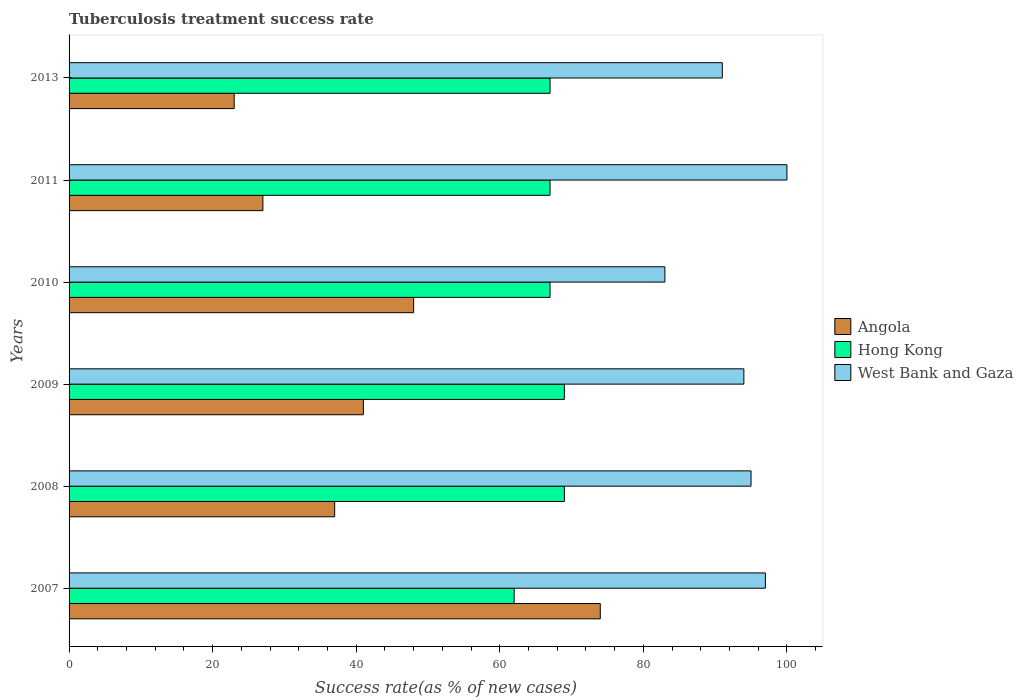How many groups of bars are there?
Your answer should be compact. 6. Are the number of bars per tick equal to the number of legend labels?
Provide a succinct answer. Yes. How many bars are there on the 5th tick from the bottom?
Offer a very short reply. 3. What is the label of the 1st group of bars from the top?
Provide a short and direct response. 2013. In how many cases, is the number of bars for a given year not equal to the number of legend labels?
Your response must be concise. 0. What is the tuberculosis treatment success rate in Angola in 2007?
Keep it short and to the point. 74. Across all years, what is the maximum tuberculosis treatment success rate in West Bank and Gaza?
Keep it short and to the point. 100. In which year was the tuberculosis treatment success rate in Angola maximum?
Give a very brief answer. 2007. What is the total tuberculosis treatment success rate in Angola in the graph?
Keep it short and to the point. 250. What is the difference between the tuberculosis treatment success rate in West Bank and Gaza in 2008 and that in 2009?
Provide a succinct answer. 1. What is the difference between the tuberculosis treatment success rate in Angola in 2007 and the tuberculosis treatment success rate in West Bank and Gaza in 2013?
Give a very brief answer. -17. What is the average tuberculosis treatment success rate in Hong Kong per year?
Keep it short and to the point. 66.83. In the year 2010, what is the difference between the tuberculosis treatment success rate in Hong Kong and tuberculosis treatment success rate in Angola?
Provide a short and direct response. 19. In how many years, is the tuberculosis treatment success rate in Hong Kong greater than 48 %?
Offer a very short reply. 6. What is the ratio of the tuberculosis treatment success rate in Hong Kong in 2008 to that in 2013?
Offer a very short reply. 1.03. Is the tuberculosis treatment success rate in Angola in 2007 less than that in 2009?
Offer a terse response. No. Is the difference between the tuberculosis treatment success rate in Hong Kong in 2009 and 2010 greater than the difference between the tuberculosis treatment success rate in Angola in 2009 and 2010?
Provide a short and direct response. Yes. What is the difference between the highest and the second highest tuberculosis treatment success rate in Hong Kong?
Offer a terse response. 0. In how many years, is the tuberculosis treatment success rate in Hong Kong greater than the average tuberculosis treatment success rate in Hong Kong taken over all years?
Offer a very short reply. 5. Is the sum of the tuberculosis treatment success rate in Hong Kong in 2009 and 2011 greater than the maximum tuberculosis treatment success rate in West Bank and Gaza across all years?
Give a very brief answer. Yes. What does the 3rd bar from the top in 2009 represents?
Ensure brevity in your answer.  Angola. What does the 1st bar from the bottom in 2009 represents?
Ensure brevity in your answer.  Angola. Is it the case that in every year, the sum of the tuberculosis treatment success rate in Hong Kong and tuberculosis treatment success rate in Angola is greater than the tuberculosis treatment success rate in West Bank and Gaza?
Your response must be concise. No. How many bars are there?
Provide a short and direct response. 18. Are all the bars in the graph horizontal?
Your answer should be compact. Yes. How many years are there in the graph?
Provide a succinct answer. 6. Does the graph contain any zero values?
Offer a very short reply. No. Does the graph contain grids?
Give a very brief answer. No. Where does the legend appear in the graph?
Provide a succinct answer. Center right. How are the legend labels stacked?
Your answer should be very brief. Vertical. What is the title of the graph?
Your response must be concise. Tuberculosis treatment success rate. Does "Lithuania" appear as one of the legend labels in the graph?
Keep it short and to the point. No. What is the label or title of the X-axis?
Give a very brief answer. Success rate(as % of new cases). What is the label or title of the Y-axis?
Your answer should be very brief. Years. What is the Success rate(as % of new cases) in Hong Kong in 2007?
Offer a terse response. 62. What is the Success rate(as % of new cases) of West Bank and Gaza in 2007?
Keep it short and to the point. 97. What is the Success rate(as % of new cases) of Hong Kong in 2008?
Make the answer very short. 69. What is the Success rate(as % of new cases) of Angola in 2009?
Your response must be concise. 41. What is the Success rate(as % of new cases) of West Bank and Gaza in 2009?
Offer a terse response. 94. What is the Success rate(as % of new cases) of Hong Kong in 2010?
Ensure brevity in your answer.  67. What is the Success rate(as % of new cases) in Hong Kong in 2013?
Your answer should be very brief. 67. What is the Success rate(as % of new cases) in West Bank and Gaza in 2013?
Offer a terse response. 91. Across all years, what is the maximum Success rate(as % of new cases) of Angola?
Offer a very short reply. 74. Across all years, what is the maximum Success rate(as % of new cases) of Hong Kong?
Make the answer very short. 69. Across all years, what is the minimum Success rate(as % of new cases) in Angola?
Provide a succinct answer. 23. What is the total Success rate(as % of new cases) in Angola in the graph?
Ensure brevity in your answer.  250. What is the total Success rate(as % of new cases) in Hong Kong in the graph?
Ensure brevity in your answer.  401. What is the total Success rate(as % of new cases) of West Bank and Gaza in the graph?
Ensure brevity in your answer.  560. What is the difference between the Success rate(as % of new cases) of Hong Kong in 2007 and that in 2008?
Keep it short and to the point. -7. What is the difference between the Success rate(as % of new cases) in West Bank and Gaza in 2007 and that in 2008?
Make the answer very short. 2. What is the difference between the Success rate(as % of new cases) in Hong Kong in 2007 and that in 2009?
Provide a succinct answer. -7. What is the difference between the Success rate(as % of new cases) in West Bank and Gaza in 2007 and that in 2009?
Give a very brief answer. 3. What is the difference between the Success rate(as % of new cases) of Angola in 2007 and that in 2010?
Provide a short and direct response. 26. What is the difference between the Success rate(as % of new cases) of Hong Kong in 2007 and that in 2010?
Provide a succinct answer. -5. What is the difference between the Success rate(as % of new cases) in Angola in 2007 and that in 2011?
Make the answer very short. 47. What is the difference between the Success rate(as % of new cases) in Hong Kong in 2007 and that in 2013?
Ensure brevity in your answer.  -5. What is the difference between the Success rate(as % of new cases) of West Bank and Gaza in 2007 and that in 2013?
Your answer should be very brief. 6. What is the difference between the Success rate(as % of new cases) of Angola in 2008 and that in 2010?
Ensure brevity in your answer.  -11. What is the difference between the Success rate(as % of new cases) of West Bank and Gaza in 2008 and that in 2011?
Offer a very short reply. -5. What is the difference between the Success rate(as % of new cases) of Angola in 2008 and that in 2013?
Ensure brevity in your answer.  14. What is the difference between the Success rate(as % of new cases) of Hong Kong in 2008 and that in 2013?
Offer a very short reply. 2. What is the difference between the Success rate(as % of new cases) in Angola in 2009 and that in 2010?
Ensure brevity in your answer.  -7. What is the difference between the Success rate(as % of new cases) in Hong Kong in 2009 and that in 2013?
Give a very brief answer. 2. What is the difference between the Success rate(as % of new cases) in West Bank and Gaza in 2009 and that in 2013?
Provide a succinct answer. 3. What is the difference between the Success rate(as % of new cases) in Angola in 2010 and that in 2011?
Your response must be concise. 21. What is the difference between the Success rate(as % of new cases) of West Bank and Gaza in 2010 and that in 2011?
Provide a succinct answer. -17. What is the difference between the Success rate(as % of new cases) of Hong Kong in 2010 and that in 2013?
Offer a very short reply. 0. What is the difference between the Success rate(as % of new cases) in Angola in 2007 and the Success rate(as % of new cases) in Hong Kong in 2008?
Provide a succinct answer. 5. What is the difference between the Success rate(as % of new cases) of Hong Kong in 2007 and the Success rate(as % of new cases) of West Bank and Gaza in 2008?
Ensure brevity in your answer.  -33. What is the difference between the Success rate(as % of new cases) of Angola in 2007 and the Success rate(as % of new cases) of West Bank and Gaza in 2009?
Offer a terse response. -20. What is the difference between the Success rate(as % of new cases) in Hong Kong in 2007 and the Success rate(as % of new cases) in West Bank and Gaza in 2009?
Keep it short and to the point. -32. What is the difference between the Success rate(as % of new cases) in Angola in 2007 and the Success rate(as % of new cases) in Hong Kong in 2010?
Provide a short and direct response. 7. What is the difference between the Success rate(as % of new cases) of Angola in 2007 and the Success rate(as % of new cases) of Hong Kong in 2011?
Make the answer very short. 7. What is the difference between the Success rate(as % of new cases) in Hong Kong in 2007 and the Success rate(as % of new cases) in West Bank and Gaza in 2011?
Give a very brief answer. -38. What is the difference between the Success rate(as % of new cases) in Hong Kong in 2007 and the Success rate(as % of new cases) in West Bank and Gaza in 2013?
Keep it short and to the point. -29. What is the difference between the Success rate(as % of new cases) of Angola in 2008 and the Success rate(as % of new cases) of Hong Kong in 2009?
Keep it short and to the point. -32. What is the difference between the Success rate(as % of new cases) of Angola in 2008 and the Success rate(as % of new cases) of West Bank and Gaza in 2009?
Offer a very short reply. -57. What is the difference between the Success rate(as % of new cases) of Hong Kong in 2008 and the Success rate(as % of new cases) of West Bank and Gaza in 2009?
Your response must be concise. -25. What is the difference between the Success rate(as % of new cases) of Angola in 2008 and the Success rate(as % of new cases) of Hong Kong in 2010?
Your response must be concise. -30. What is the difference between the Success rate(as % of new cases) in Angola in 2008 and the Success rate(as % of new cases) in West Bank and Gaza in 2010?
Offer a very short reply. -46. What is the difference between the Success rate(as % of new cases) of Angola in 2008 and the Success rate(as % of new cases) of West Bank and Gaza in 2011?
Give a very brief answer. -63. What is the difference between the Success rate(as % of new cases) of Hong Kong in 2008 and the Success rate(as % of new cases) of West Bank and Gaza in 2011?
Offer a very short reply. -31. What is the difference between the Success rate(as % of new cases) in Angola in 2008 and the Success rate(as % of new cases) in West Bank and Gaza in 2013?
Ensure brevity in your answer.  -54. What is the difference between the Success rate(as % of new cases) in Angola in 2009 and the Success rate(as % of new cases) in West Bank and Gaza in 2010?
Provide a short and direct response. -42. What is the difference between the Success rate(as % of new cases) of Hong Kong in 2009 and the Success rate(as % of new cases) of West Bank and Gaza in 2010?
Keep it short and to the point. -14. What is the difference between the Success rate(as % of new cases) in Angola in 2009 and the Success rate(as % of new cases) in West Bank and Gaza in 2011?
Your response must be concise. -59. What is the difference between the Success rate(as % of new cases) in Hong Kong in 2009 and the Success rate(as % of new cases) in West Bank and Gaza in 2011?
Offer a terse response. -31. What is the difference between the Success rate(as % of new cases) in Angola in 2009 and the Success rate(as % of new cases) in Hong Kong in 2013?
Offer a terse response. -26. What is the difference between the Success rate(as % of new cases) of Angola in 2010 and the Success rate(as % of new cases) of Hong Kong in 2011?
Give a very brief answer. -19. What is the difference between the Success rate(as % of new cases) in Angola in 2010 and the Success rate(as % of new cases) in West Bank and Gaza in 2011?
Offer a terse response. -52. What is the difference between the Success rate(as % of new cases) in Hong Kong in 2010 and the Success rate(as % of new cases) in West Bank and Gaza in 2011?
Offer a very short reply. -33. What is the difference between the Success rate(as % of new cases) of Angola in 2010 and the Success rate(as % of new cases) of Hong Kong in 2013?
Keep it short and to the point. -19. What is the difference between the Success rate(as % of new cases) of Angola in 2010 and the Success rate(as % of new cases) of West Bank and Gaza in 2013?
Give a very brief answer. -43. What is the difference between the Success rate(as % of new cases) of Hong Kong in 2010 and the Success rate(as % of new cases) of West Bank and Gaza in 2013?
Your answer should be very brief. -24. What is the difference between the Success rate(as % of new cases) in Angola in 2011 and the Success rate(as % of new cases) in West Bank and Gaza in 2013?
Offer a very short reply. -64. What is the difference between the Success rate(as % of new cases) of Hong Kong in 2011 and the Success rate(as % of new cases) of West Bank and Gaza in 2013?
Your answer should be very brief. -24. What is the average Success rate(as % of new cases) of Angola per year?
Offer a very short reply. 41.67. What is the average Success rate(as % of new cases) of Hong Kong per year?
Provide a short and direct response. 66.83. What is the average Success rate(as % of new cases) in West Bank and Gaza per year?
Offer a terse response. 93.33. In the year 2007, what is the difference between the Success rate(as % of new cases) of Angola and Success rate(as % of new cases) of Hong Kong?
Provide a short and direct response. 12. In the year 2007, what is the difference between the Success rate(as % of new cases) of Angola and Success rate(as % of new cases) of West Bank and Gaza?
Ensure brevity in your answer.  -23. In the year 2007, what is the difference between the Success rate(as % of new cases) of Hong Kong and Success rate(as % of new cases) of West Bank and Gaza?
Ensure brevity in your answer.  -35. In the year 2008, what is the difference between the Success rate(as % of new cases) in Angola and Success rate(as % of new cases) in Hong Kong?
Provide a succinct answer. -32. In the year 2008, what is the difference between the Success rate(as % of new cases) of Angola and Success rate(as % of new cases) of West Bank and Gaza?
Give a very brief answer. -58. In the year 2008, what is the difference between the Success rate(as % of new cases) in Hong Kong and Success rate(as % of new cases) in West Bank and Gaza?
Ensure brevity in your answer.  -26. In the year 2009, what is the difference between the Success rate(as % of new cases) in Angola and Success rate(as % of new cases) in West Bank and Gaza?
Offer a terse response. -53. In the year 2009, what is the difference between the Success rate(as % of new cases) of Hong Kong and Success rate(as % of new cases) of West Bank and Gaza?
Offer a very short reply. -25. In the year 2010, what is the difference between the Success rate(as % of new cases) in Angola and Success rate(as % of new cases) in Hong Kong?
Offer a terse response. -19. In the year 2010, what is the difference between the Success rate(as % of new cases) of Angola and Success rate(as % of new cases) of West Bank and Gaza?
Offer a terse response. -35. In the year 2010, what is the difference between the Success rate(as % of new cases) in Hong Kong and Success rate(as % of new cases) in West Bank and Gaza?
Your answer should be very brief. -16. In the year 2011, what is the difference between the Success rate(as % of new cases) of Angola and Success rate(as % of new cases) of Hong Kong?
Your response must be concise. -40. In the year 2011, what is the difference between the Success rate(as % of new cases) in Angola and Success rate(as % of new cases) in West Bank and Gaza?
Your response must be concise. -73. In the year 2011, what is the difference between the Success rate(as % of new cases) in Hong Kong and Success rate(as % of new cases) in West Bank and Gaza?
Provide a short and direct response. -33. In the year 2013, what is the difference between the Success rate(as % of new cases) in Angola and Success rate(as % of new cases) in Hong Kong?
Give a very brief answer. -44. In the year 2013, what is the difference between the Success rate(as % of new cases) of Angola and Success rate(as % of new cases) of West Bank and Gaza?
Make the answer very short. -68. In the year 2013, what is the difference between the Success rate(as % of new cases) in Hong Kong and Success rate(as % of new cases) in West Bank and Gaza?
Your answer should be compact. -24. What is the ratio of the Success rate(as % of new cases) of Hong Kong in 2007 to that in 2008?
Make the answer very short. 0.9. What is the ratio of the Success rate(as % of new cases) of West Bank and Gaza in 2007 to that in 2008?
Your answer should be compact. 1.02. What is the ratio of the Success rate(as % of new cases) in Angola in 2007 to that in 2009?
Your answer should be compact. 1.8. What is the ratio of the Success rate(as % of new cases) of Hong Kong in 2007 to that in 2009?
Provide a short and direct response. 0.9. What is the ratio of the Success rate(as % of new cases) of West Bank and Gaza in 2007 to that in 2009?
Ensure brevity in your answer.  1.03. What is the ratio of the Success rate(as % of new cases) in Angola in 2007 to that in 2010?
Give a very brief answer. 1.54. What is the ratio of the Success rate(as % of new cases) in Hong Kong in 2007 to that in 2010?
Your answer should be compact. 0.93. What is the ratio of the Success rate(as % of new cases) in West Bank and Gaza in 2007 to that in 2010?
Your response must be concise. 1.17. What is the ratio of the Success rate(as % of new cases) in Angola in 2007 to that in 2011?
Keep it short and to the point. 2.74. What is the ratio of the Success rate(as % of new cases) in Hong Kong in 2007 to that in 2011?
Provide a succinct answer. 0.93. What is the ratio of the Success rate(as % of new cases) in Angola in 2007 to that in 2013?
Provide a short and direct response. 3.22. What is the ratio of the Success rate(as % of new cases) in Hong Kong in 2007 to that in 2013?
Your response must be concise. 0.93. What is the ratio of the Success rate(as % of new cases) of West Bank and Gaza in 2007 to that in 2013?
Offer a terse response. 1.07. What is the ratio of the Success rate(as % of new cases) in Angola in 2008 to that in 2009?
Offer a terse response. 0.9. What is the ratio of the Success rate(as % of new cases) in Hong Kong in 2008 to that in 2009?
Make the answer very short. 1. What is the ratio of the Success rate(as % of new cases) of West Bank and Gaza in 2008 to that in 2009?
Give a very brief answer. 1.01. What is the ratio of the Success rate(as % of new cases) of Angola in 2008 to that in 2010?
Give a very brief answer. 0.77. What is the ratio of the Success rate(as % of new cases) of Hong Kong in 2008 to that in 2010?
Keep it short and to the point. 1.03. What is the ratio of the Success rate(as % of new cases) in West Bank and Gaza in 2008 to that in 2010?
Your response must be concise. 1.14. What is the ratio of the Success rate(as % of new cases) in Angola in 2008 to that in 2011?
Keep it short and to the point. 1.37. What is the ratio of the Success rate(as % of new cases) of Hong Kong in 2008 to that in 2011?
Keep it short and to the point. 1.03. What is the ratio of the Success rate(as % of new cases) of Angola in 2008 to that in 2013?
Provide a short and direct response. 1.61. What is the ratio of the Success rate(as % of new cases) in Hong Kong in 2008 to that in 2013?
Give a very brief answer. 1.03. What is the ratio of the Success rate(as % of new cases) of West Bank and Gaza in 2008 to that in 2013?
Give a very brief answer. 1.04. What is the ratio of the Success rate(as % of new cases) of Angola in 2009 to that in 2010?
Provide a succinct answer. 0.85. What is the ratio of the Success rate(as % of new cases) of Hong Kong in 2009 to that in 2010?
Your response must be concise. 1.03. What is the ratio of the Success rate(as % of new cases) of West Bank and Gaza in 2009 to that in 2010?
Ensure brevity in your answer.  1.13. What is the ratio of the Success rate(as % of new cases) of Angola in 2009 to that in 2011?
Provide a short and direct response. 1.52. What is the ratio of the Success rate(as % of new cases) of Hong Kong in 2009 to that in 2011?
Provide a succinct answer. 1.03. What is the ratio of the Success rate(as % of new cases) in Angola in 2009 to that in 2013?
Offer a terse response. 1.78. What is the ratio of the Success rate(as % of new cases) in Hong Kong in 2009 to that in 2013?
Provide a succinct answer. 1.03. What is the ratio of the Success rate(as % of new cases) in West Bank and Gaza in 2009 to that in 2013?
Offer a very short reply. 1.03. What is the ratio of the Success rate(as % of new cases) of Angola in 2010 to that in 2011?
Give a very brief answer. 1.78. What is the ratio of the Success rate(as % of new cases) in Hong Kong in 2010 to that in 2011?
Provide a succinct answer. 1. What is the ratio of the Success rate(as % of new cases) in West Bank and Gaza in 2010 to that in 2011?
Your answer should be compact. 0.83. What is the ratio of the Success rate(as % of new cases) of Angola in 2010 to that in 2013?
Offer a very short reply. 2.09. What is the ratio of the Success rate(as % of new cases) of Hong Kong in 2010 to that in 2013?
Provide a short and direct response. 1. What is the ratio of the Success rate(as % of new cases) in West Bank and Gaza in 2010 to that in 2013?
Keep it short and to the point. 0.91. What is the ratio of the Success rate(as % of new cases) in Angola in 2011 to that in 2013?
Keep it short and to the point. 1.17. What is the ratio of the Success rate(as % of new cases) of Hong Kong in 2011 to that in 2013?
Offer a terse response. 1. What is the ratio of the Success rate(as % of new cases) of West Bank and Gaza in 2011 to that in 2013?
Keep it short and to the point. 1.1. What is the difference between the highest and the second highest Success rate(as % of new cases) in Angola?
Your response must be concise. 26. What is the difference between the highest and the second highest Success rate(as % of new cases) of Hong Kong?
Make the answer very short. 0. What is the difference between the highest and the lowest Success rate(as % of new cases) in Hong Kong?
Your response must be concise. 7. 